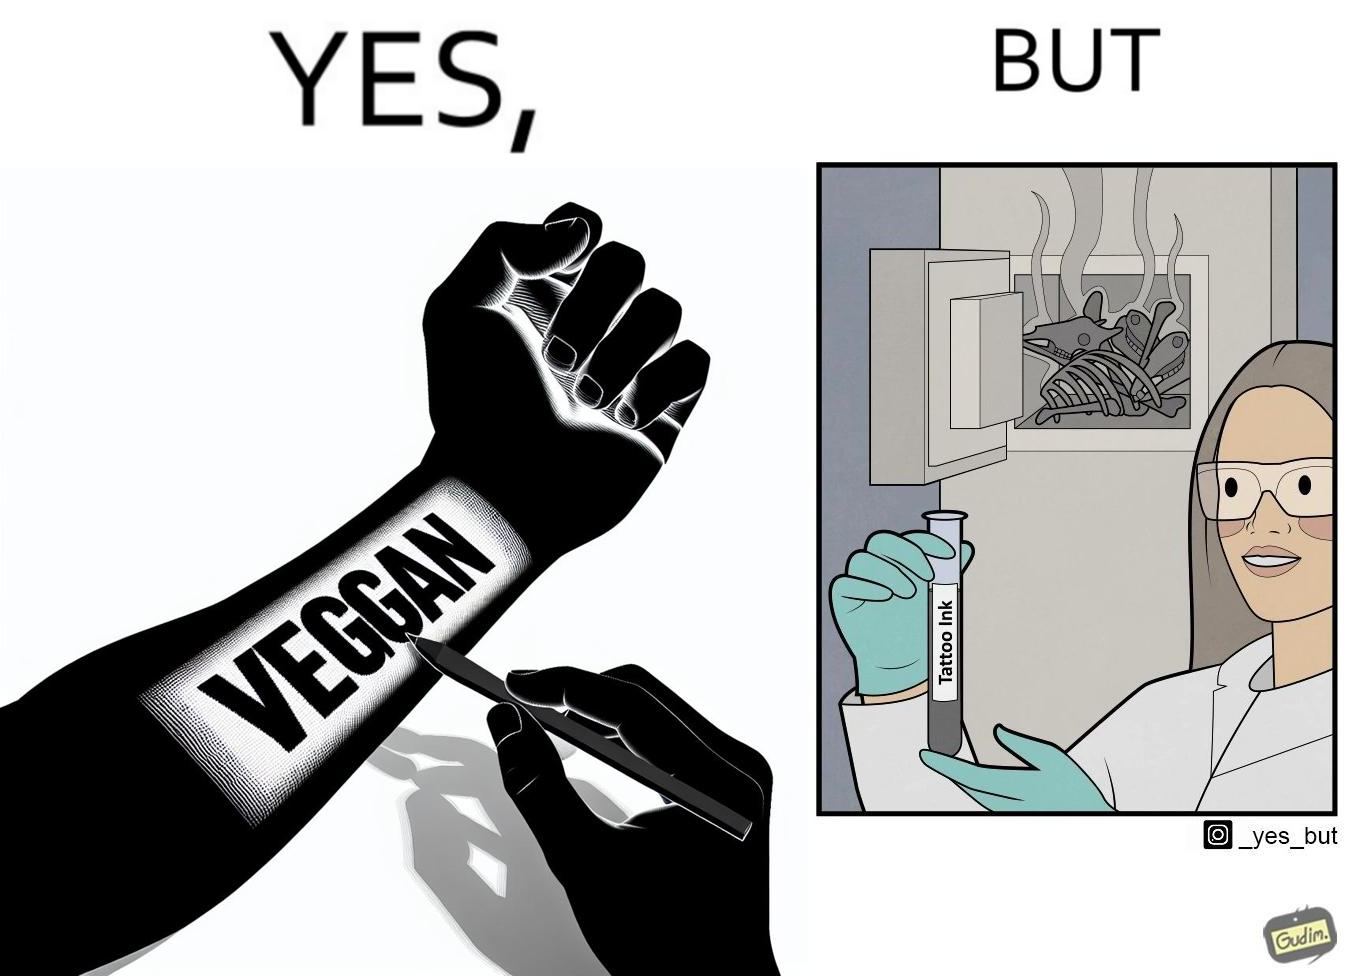Describe what you see in this image. The irony in this video is that people try to promote and embrace veganism end up using products that are not animal-free. 